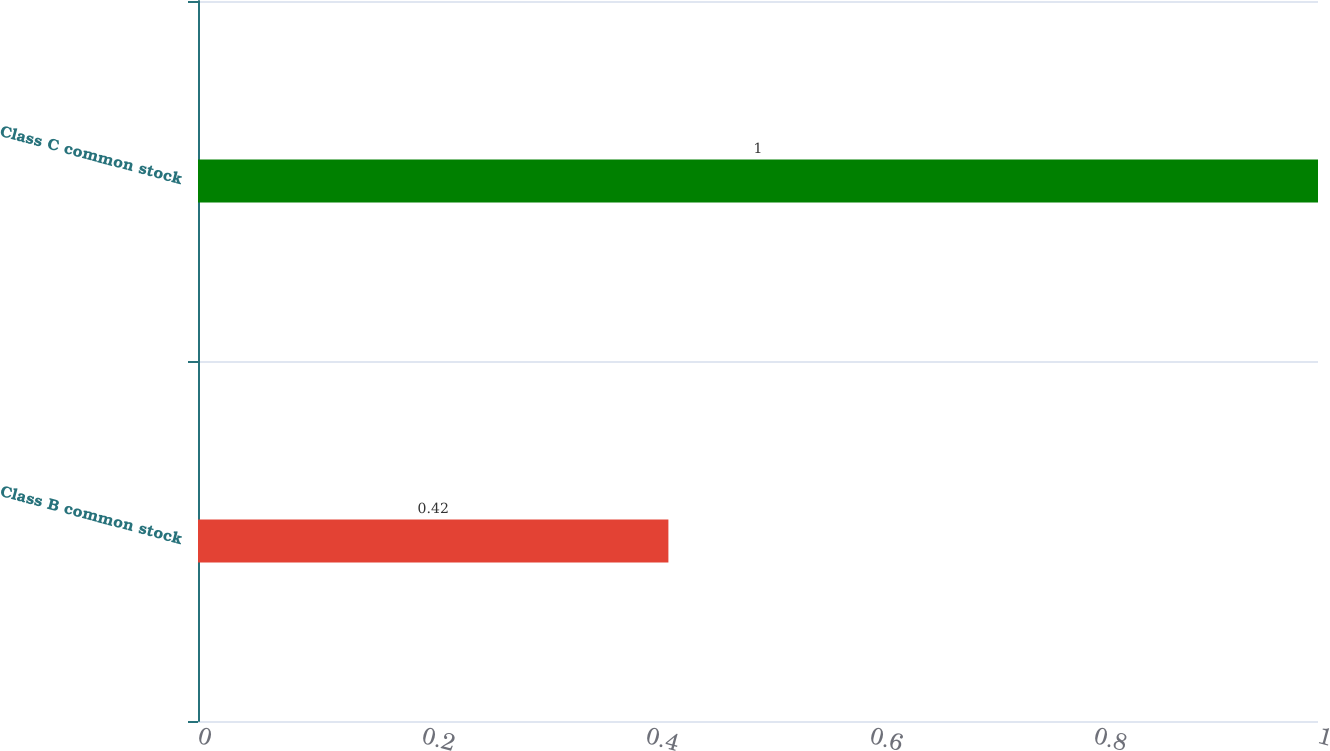<chart> <loc_0><loc_0><loc_500><loc_500><bar_chart><fcel>Class B common stock<fcel>Class C common stock<nl><fcel>0.42<fcel>1<nl></chart> 